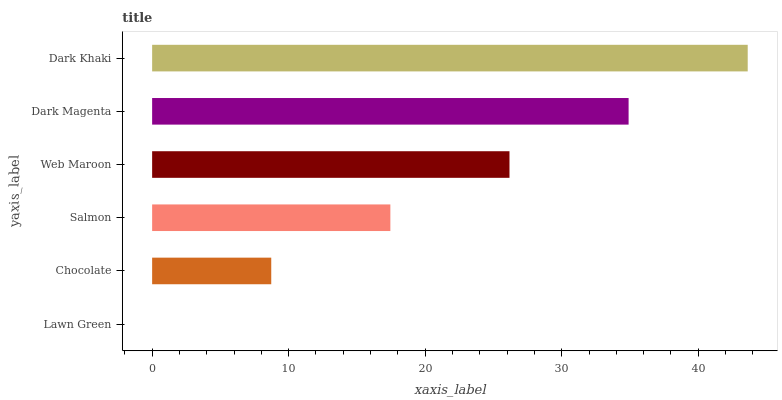Is Lawn Green the minimum?
Answer yes or no. Yes. Is Dark Khaki the maximum?
Answer yes or no. Yes. Is Chocolate the minimum?
Answer yes or no. No. Is Chocolate the maximum?
Answer yes or no. No. Is Chocolate greater than Lawn Green?
Answer yes or no. Yes. Is Lawn Green less than Chocolate?
Answer yes or no. Yes. Is Lawn Green greater than Chocolate?
Answer yes or no. No. Is Chocolate less than Lawn Green?
Answer yes or no. No. Is Web Maroon the high median?
Answer yes or no. Yes. Is Salmon the low median?
Answer yes or no. Yes. Is Chocolate the high median?
Answer yes or no. No. Is Lawn Green the low median?
Answer yes or no. No. 